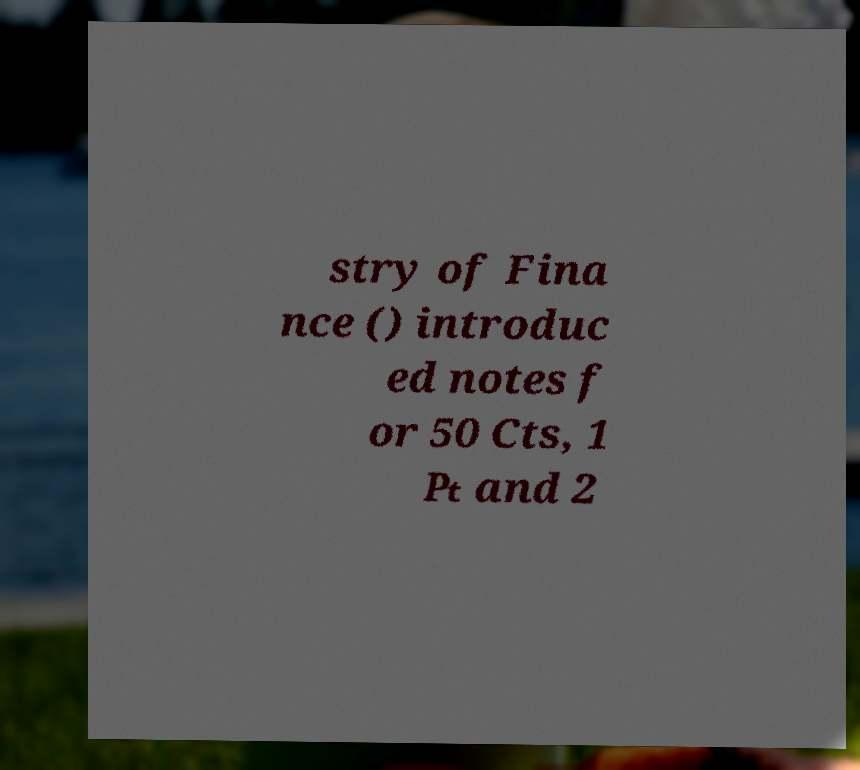Could you assist in decoding the text presented in this image and type it out clearly? stry of Fina nce () introduc ed notes f or 50 Cts, 1 ₧ and 2 